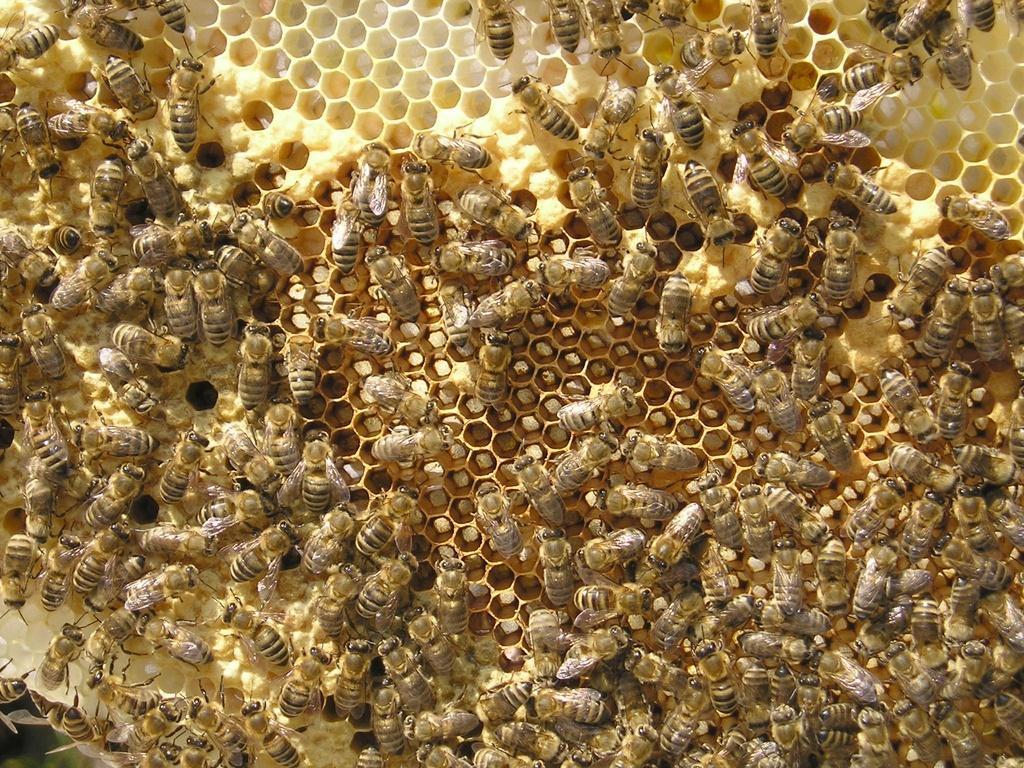Could you give a brief overview of what you see in this image? As we can see in the image there are group of honey bees. 